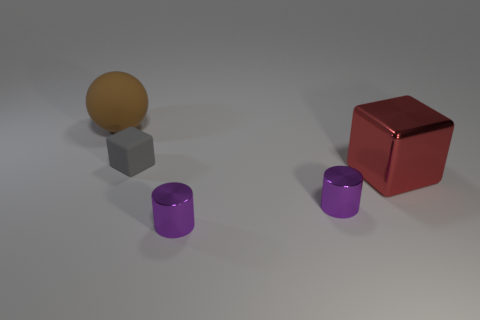Add 5 cyan metal cubes. How many objects exist? 10 Subtract all cubes. How many objects are left? 3 Add 1 small gray cubes. How many small gray cubes exist? 2 Subtract 0 brown cubes. How many objects are left? 5 Subtract all big matte things. Subtract all red metallic cubes. How many objects are left? 3 Add 5 tiny metal objects. How many tiny metal objects are left? 7 